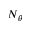<formula> <loc_0><loc_0><loc_500><loc_500>N _ { \theta }</formula> 